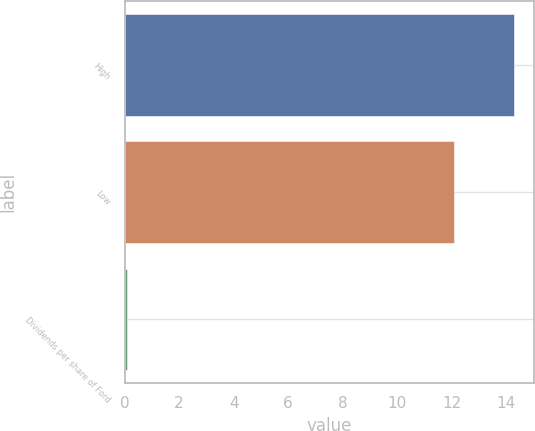Convert chart. <chart><loc_0><loc_0><loc_500><loc_500><bar_chart><fcel>High<fcel>Low<fcel>Dividends per share of Ford<nl><fcel>14.3<fcel>12.1<fcel>0.1<nl></chart> 